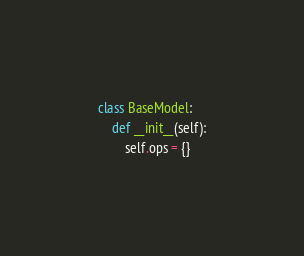Convert code to text. <code><loc_0><loc_0><loc_500><loc_500><_Python_>class BaseModel:
    def __init__(self):
        self.ops = {}
</code> 